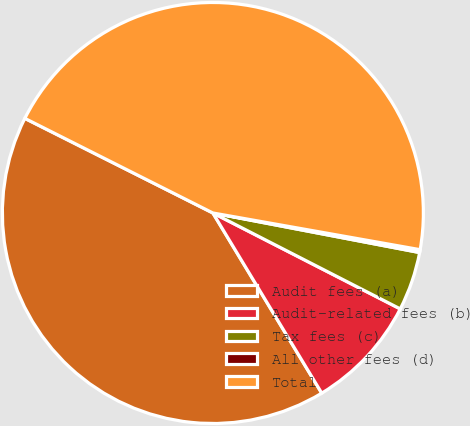Convert chart to OTSL. <chart><loc_0><loc_0><loc_500><loc_500><pie_chart><fcel>Audit fees (a)<fcel>Audit-related fees (b)<fcel>Tax fees (c)<fcel>All other fees (d)<fcel>Total<nl><fcel>41.07%<fcel>8.82%<fcel>4.52%<fcel>0.22%<fcel>45.37%<nl></chart> 